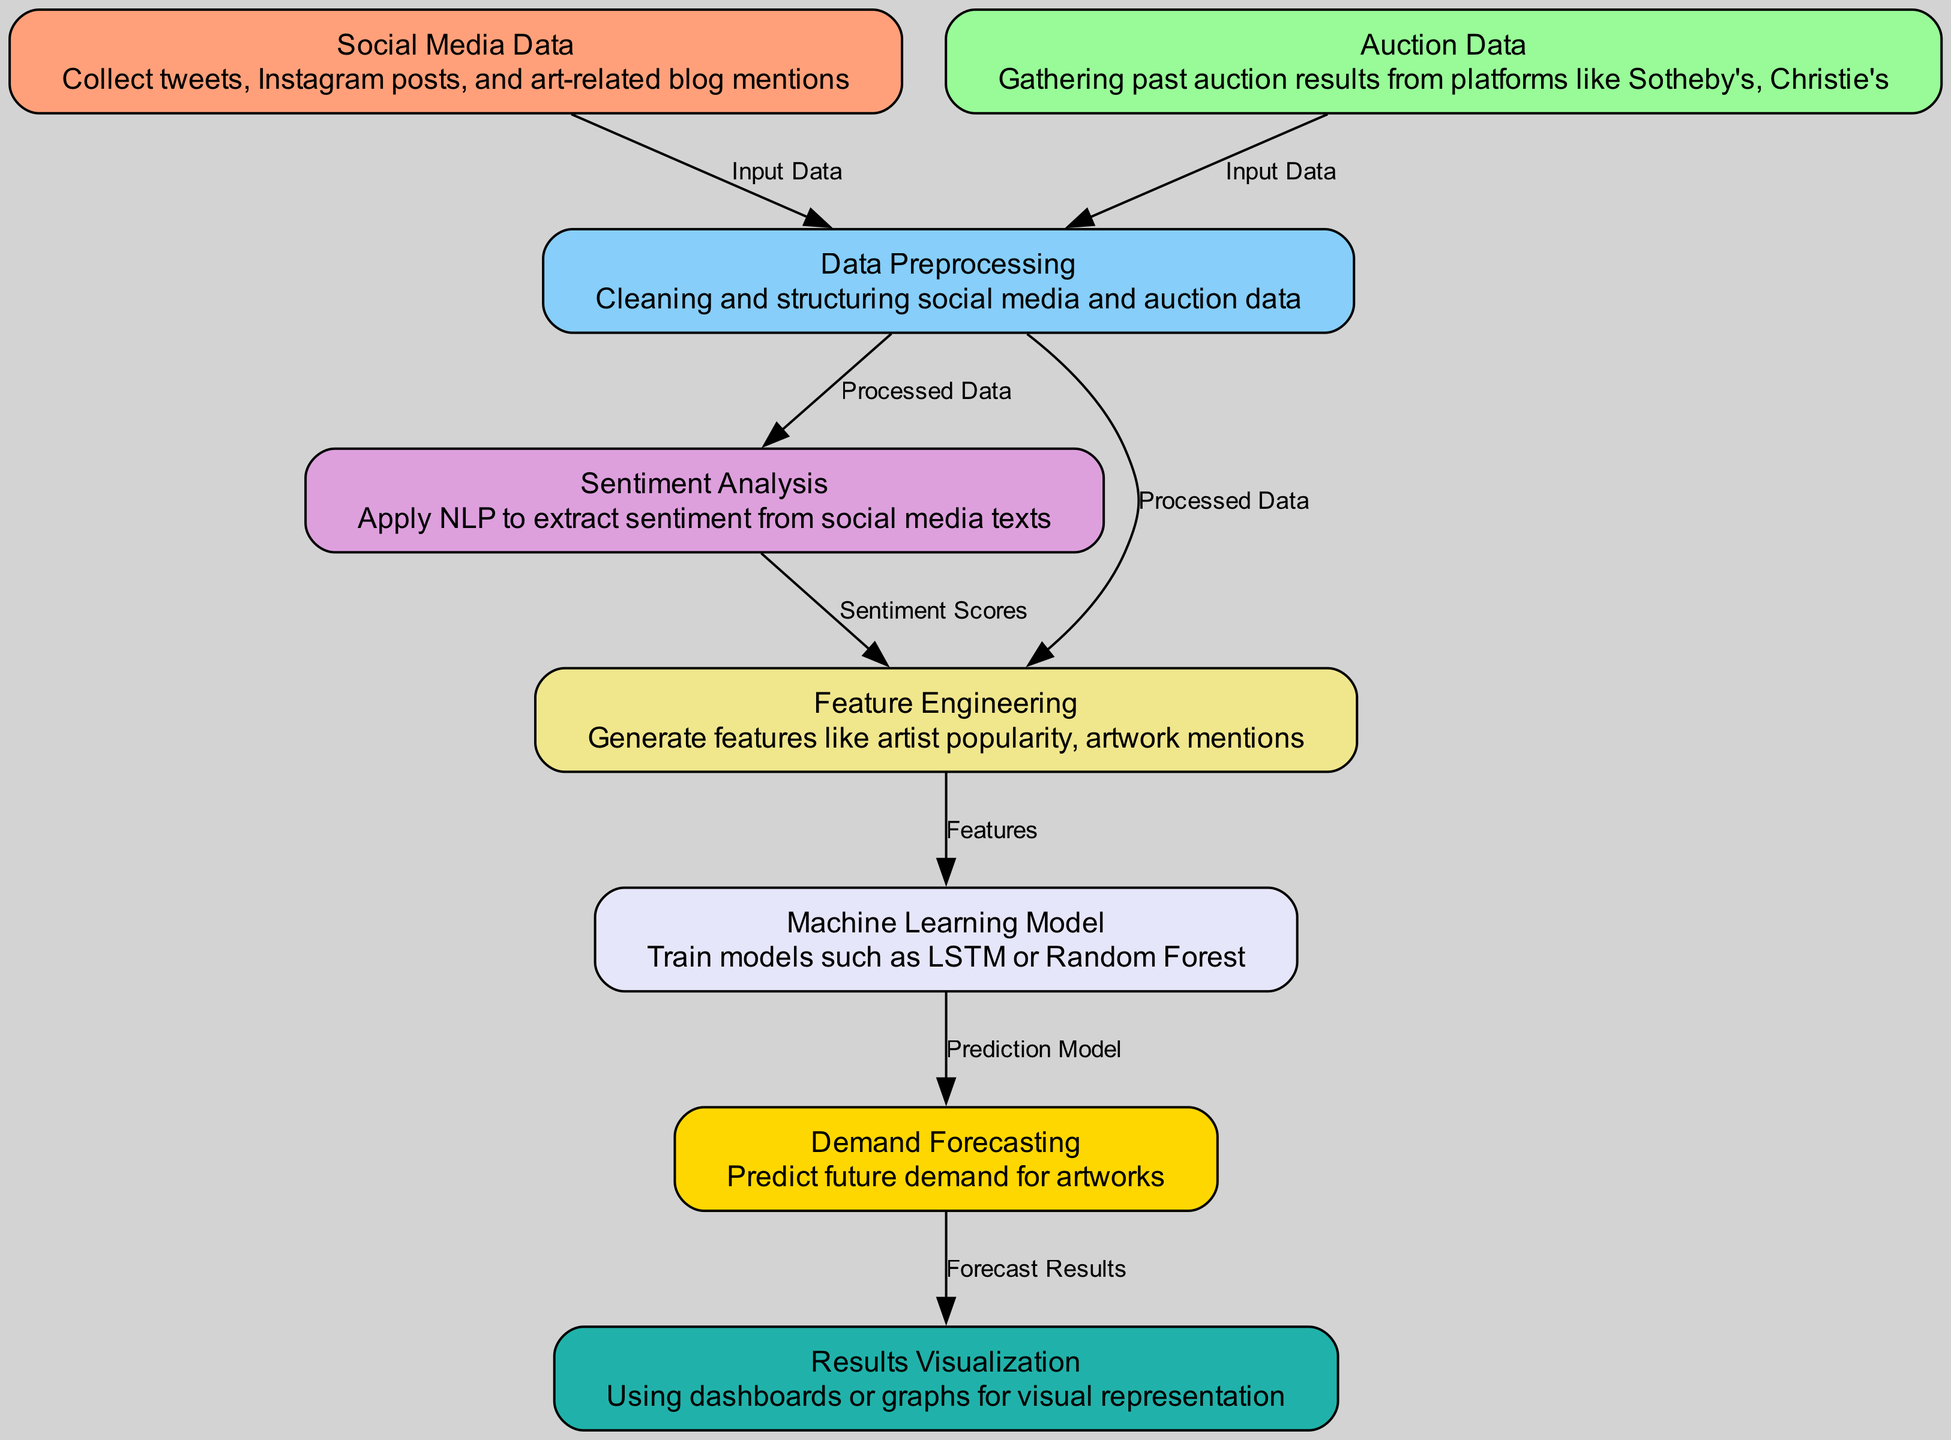What is the first data source used in the diagram? The diagram starts with the "Social Media Data" node, indicating that it is the first data source collected.
Answer: Social Media Data How many nodes are present in the diagram? By counting the nodes listed in the diagram, there are a total of 8 nodes involved in the process.
Answer: 8 What type of data is gathered from "Auction Data"? The "Auction Data" node is described as gathering past auction results from various auction houses, focusing on auction-related historical data.
Answer: Past auction results Which nodes are connected to "Data Preprocessing"? Two edges lead to "Data Preprocessing": one from "Social Media Data" and the other from "Auction Data," indicating both data types are processed.
Answer: Social Media Data, Auction Data What predicts the future demand for artworks? The diagram indicates that the "Machine Learning Model" outputs into the next process, which is "Demand Forecasting," thus predicting future demand.
Answer: Demand Forecasting Which node provides sentiment scores? The node labeled "Sentiment Analysis" is responsible for applying natural language processing to extract sentiment from social media texts, thus providing sentiment scores.
Answer: Sentiment Analysis What do the features generated in "Feature Engineering" originate from? The features generated originate from "Processed Data" from the "Data Preprocessing" node and "Sentiment Scores" from the "Sentiment Analysis" node, showing how both contribute to features.
Answer: Processed Data, Sentiment Scores How do results get visualized? The "Results Visualization" node receives "Forecast Results" from "Demand Forecasting," indicating that the forecasted outcomes are then represented visually through dashboards or graphs.
Answer: Using dashboards or graphs 